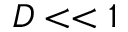Convert formula to latex. <formula><loc_0><loc_0><loc_500><loc_500>D < < 1</formula> 